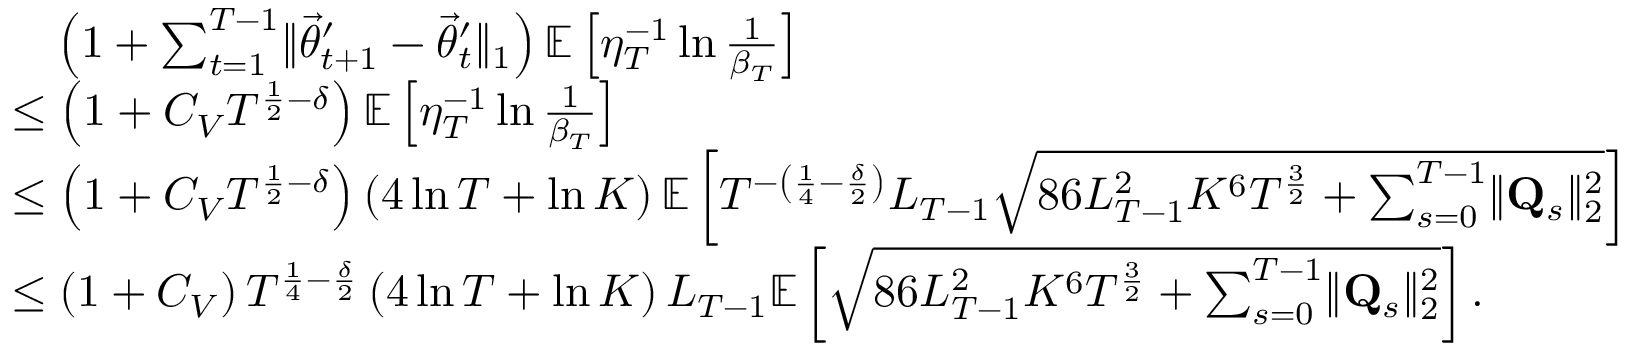Convert formula to latex. <formula><loc_0><loc_0><loc_500><loc_500>\begin{array} { r l } & { \quad \left ( 1 + \sum _ { t = 1 } ^ { T - 1 } \| \vec { \theta } _ { t + 1 } ^ { \prime } - \vec { \theta } _ { t } ^ { \prime } \| _ { 1 } \right ) \mathbb { E } \left [ \eta _ { T } ^ { - 1 } \ln \frac { 1 } \beta _ { T } } \right ] } \\ & { \leq \left ( 1 + C _ { V } T ^ { \frac { 1 } { 2 } - \delta } \right ) \mathbb { E } \left [ \eta _ { T } ^ { - 1 } \ln \frac { 1 } \beta _ { T } } \right ] } \\ & { \leq \left ( 1 + C _ { V } T ^ { \frac { 1 } { 2 } - \delta } \right ) \left ( 4 \ln T + \ln K \right ) \mathbb { E } \left [ T ^ { - \left ( \frac { 1 } { 4 } - \frac { \delta } { 2 } \right ) } L _ { T - 1 } \sqrt { 8 6 L _ { T - 1 } ^ { 2 } K ^ { 6 } T ^ { \frac { 3 } { 2 } } + \sum _ { s = 0 } ^ { T - 1 } \| \mathbf Q _ { s } \| _ { 2 } ^ { 2 } } \right ] } \\ & { \leq \left ( 1 + C _ { V } \right ) T ^ { \frac { 1 } { 4 } - \frac { \delta } { 2 } } \left ( 4 \ln T + \ln K \right ) L _ { T - 1 } \mathbb { E } \left [ \sqrt { 8 6 L _ { T - 1 } ^ { 2 } K ^ { 6 } T ^ { \frac { 3 } { 2 } } + \sum _ { s = 0 } ^ { T - 1 } \| \mathbf Q _ { s } \| _ { 2 } ^ { 2 } } \right ] . } \end{array}</formula> 